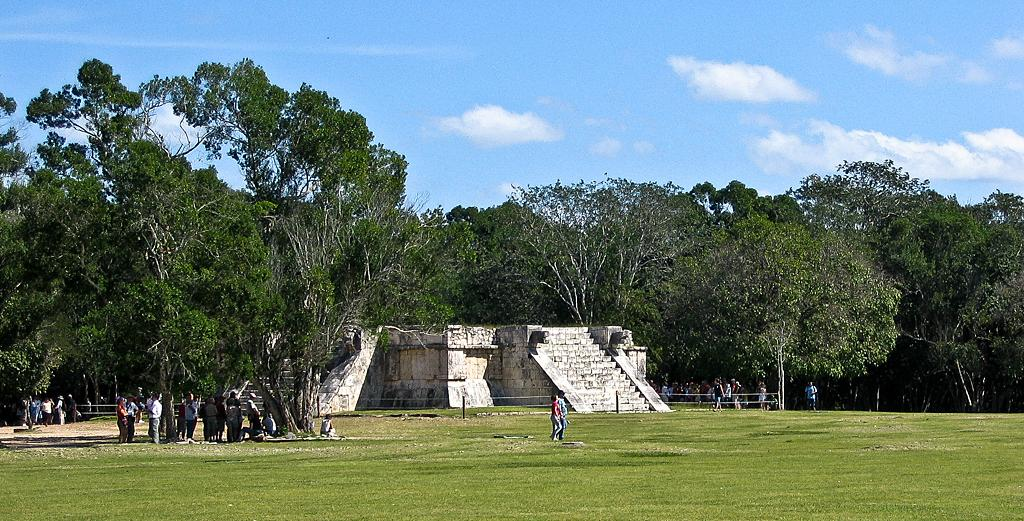What type of vegetation can be seen in the image? There is grass in the image. Can you describe the people in the image? There is a group of people in the image. What structures are present in the image? There are poles, walls, and steps in the image. What other natural elements can be seen in the image? There are trees in the image. What is visible in the background of the image? The sky is visible in the background of the image. What can be seen in the sky? Clouds are present in the sky. What type of advice is being given by the carriage in the image? There is no carriage present in the image, so it is not possible to determine what advice might be given. 